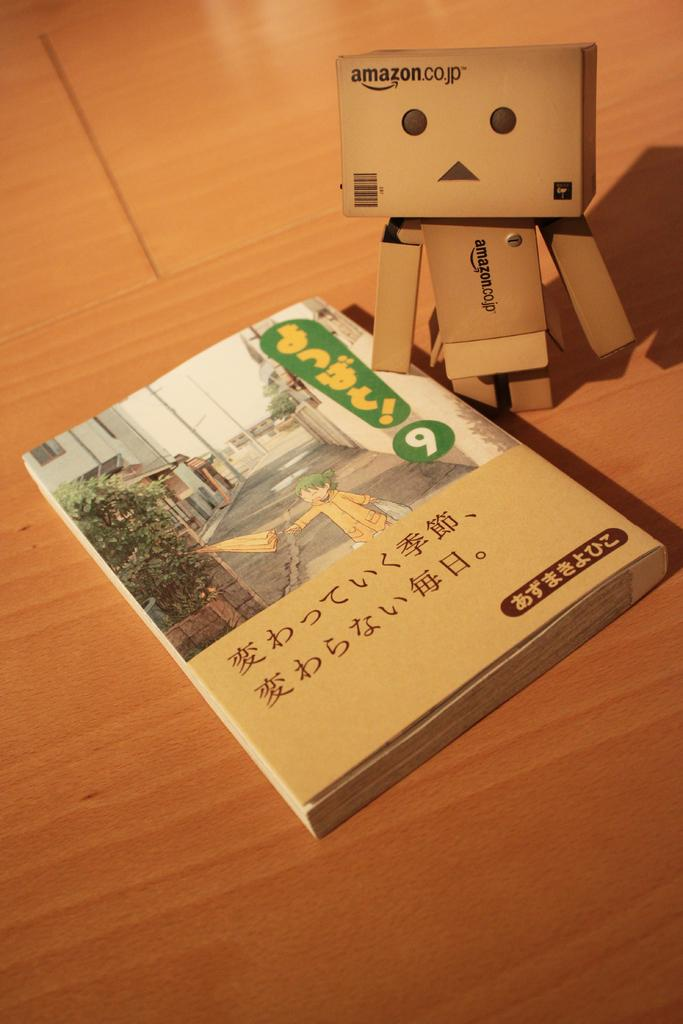<image>
Share a concise interpretation of the image provided. A book is next to a boxy figure with the word amazon on it. 